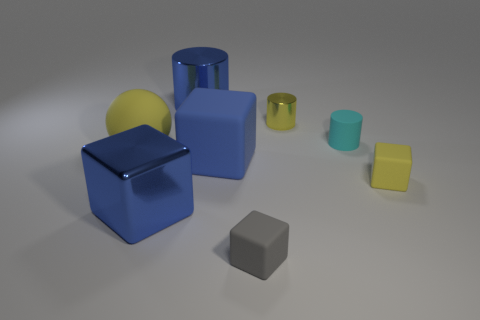There is a rubber thing that is the same color as the metal block; what shape is it?
Your response must be concise. Cube. Are any blue spheres visible?
Your answer should be very brief. No. What is the color of the large rubber thing to the right of the large yellow rubber ball on the left side of the rubber object that is in front of the large blue metal block?
Keep it short and to the point. Blue. Are there the same number of tiny cubes on the left side of the yellow metallic object and big metal cylinders behind the large blue metallic block?
Keep it short and to the point. Yes. What is the shape of the other matte thing that is the same size as the blue rubber object?
Your answer should be very brief. Sphere. Is there a large sphere of the same color as the metallic cube?
Provide a succinct answer. No. There is a small yellow metal thing that is behind the yellow block; what is its shape?
Keep it short and to the point. Cylinder. What color is the large cylinder?
Offer a very short reply. Blue. The other tiny cube that is the same material as the tiny yellow cube is what color?
Provide a short and direct response. Gray. What number of small gray cubes have the same material as the gray thing?
Your response must be concise. 0. 